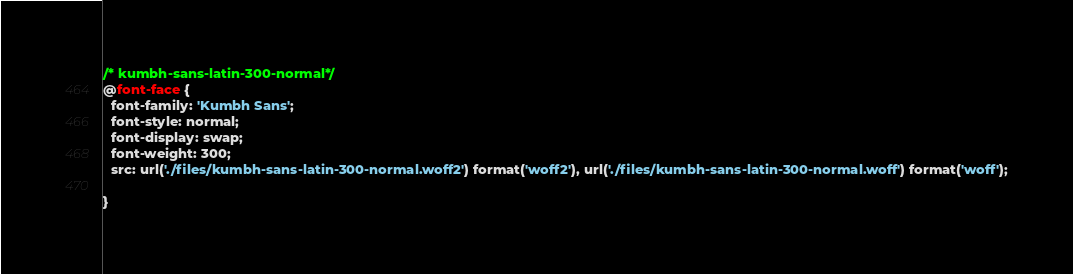<code> <loc_0><loc_0><loc_500><loc_500><_CSS_>/* kumbh-sans-latin-300-normal*/
@font-face {
  font-family: 'Kumbh Sans';
  font-style: normal;
  font-display: swap;
  font-weight: 300;
  src: url('./files/kumbh-sans-latin-300-normal.woff2') format('woff2'), url('./files/kumbh-sans-latin-300-normal.woff') format('woff');
  
}
</code> 